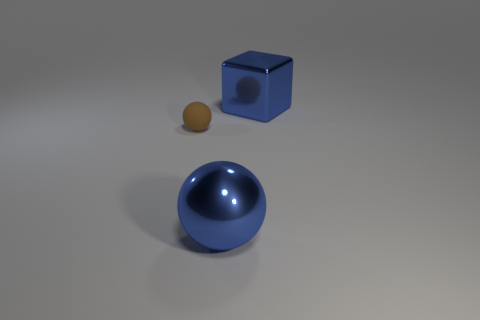Add 3 big cyan cylinders. How many objects exist? 6 Subtract all balls. How many objects are left? 1 Add 1 large shiny objects. How many large shiny objects are left? 3 Add 1 blue metallic blocks. How many blue metallic blocks exist? 2 Subtract 0 green balls. How many objects are left? 3 Subtract all tiny blue rubber spheres. Subtract all big balls. How many objects are left? 2 